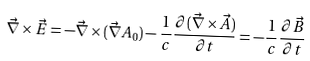Convert formula to latex. <formula><loc_0><loc_0><loc_500><loc_500>\vec { \nabla } \times \vec { E } = - \vec { \nabla } \times ( \vec { \nabla } A _ { 0 } ) - \frac { 1 } { c } \frac { \partial ( \vec { \nabla } \times \vec { A } ) } { \partial t } = - \frac { 1 } { c } \frac { \partial \vec { B } } { \partial t }</formula> 